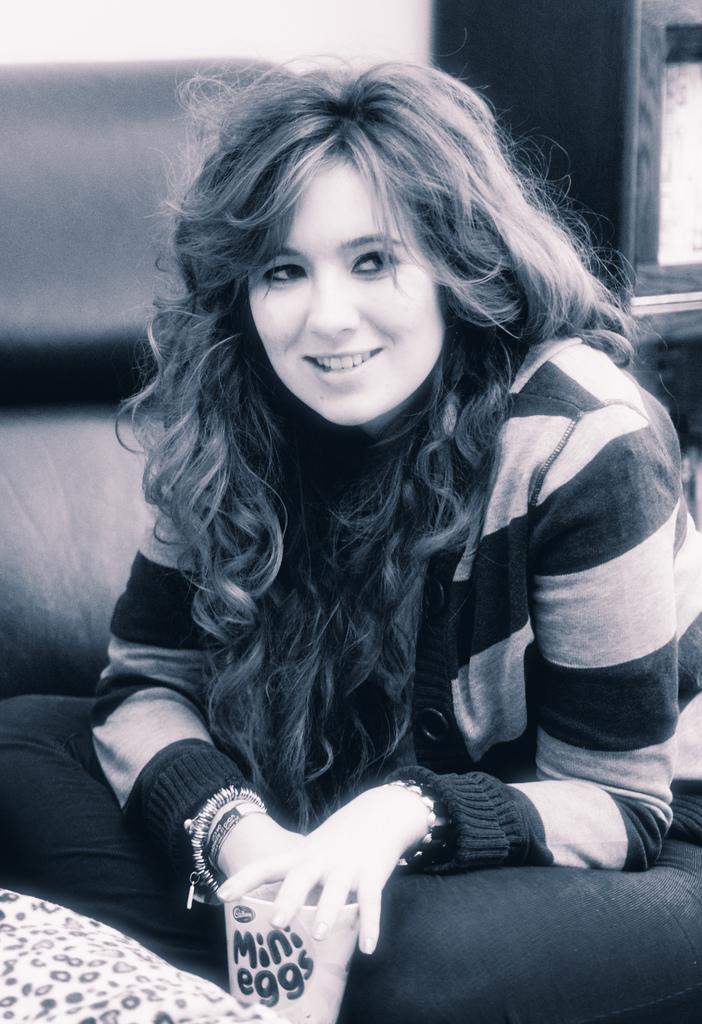Please provide a concise description of this image. In this image I can see the person is sitting and smiling. I can see a cup and few objects at back. The image is in black and white. 